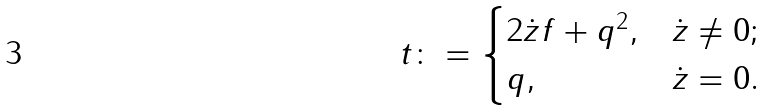Convert formula to latex. <formula><loc_0><loc_0><loc_500><loc_500>t \colon = \begin{cases} 2 { \dot { z } } f + q ^ { 2 } , & \dot { z } \neq 0 ; \\ q , & \dot { z } = 0 . \end{cases}</formula> 